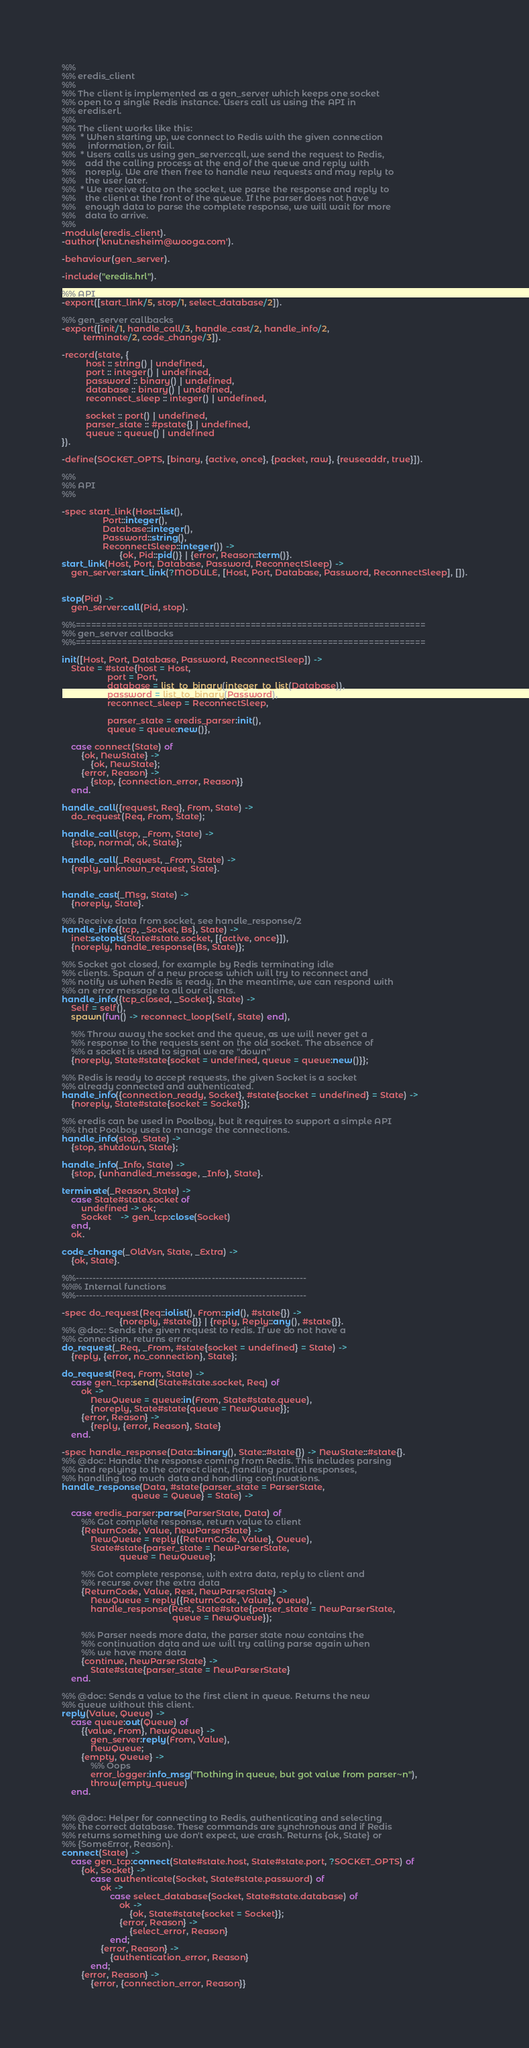Convert code to text. <code><loc_0><loc_0><loc_500><loc_500><_Erlang_>%%
%% eredis_client
%%
%% The client is implemented as a gen_server which keeps one socket
%% open to a single Redis instance. Users call us using the API in
%% eredis.erl.
%%
%% The client works like this:
%%  * When starting up, we connect to Redis with the given connection
%%     information, or fail.
%%  * Users calls us using gen_server:call, we send the request to Redis,
%%    add the calling process at the end of the queue and reply with
%%    noreply. We are then free to handle new requests and may reply to
%%    the user later.
%%  * We receive data on the socket, we parse the response and reply to
%%    the client at the front of the queue. If the parser does not have
%%    enough data to parse the complete response, we will wait for more
%%    data to arrive.
%%
-module(eredis_client).
-author('knut.nesheim@wooga.com').

-behaviour(gen_server).

-include("eredis.hrl").

%% API
-export([start_link/5, stop/1, select_database/2]).

%% gen_server callbacks
-export([init/1, handle_call/3, handle_cast/2, handle_info/2,
         terminate/2, code_change/3]).

-record(state, {
          host :: string() | undefined,
          port :: integer() | undefined,
          password :: binary() | undefined,
          database :: binary() | undefined,
          reconnect_sleep :: integer() | undefined,

          socket :: port() | undefined,
          parser_state :: #pstate{} | undefined,
          queue :: queue() | undefined
}).

-define(SOCKET_OPTS, [binary, {active, once}, {packet, raw}, {reuseaddr, true}]).

%%
%% API
%%

-spec start_link(Host::list(),
                 Port::integer(),
                 Database::integer(),
                 Password::string(),
                 ReconnectSleep::integer()) ->
                        {ok, Pid::pid()} | {error, Reason::term()}.
start_link(Host, Port, Database, Password, ReconnectSleep) ->
    gen_server:start_link(?MODULE, [Host, Port, Database, Password, ReconnectSleep], []).


stop(Pid) ->
    gen_server:call(Pid, stop).

%%====================================================================
%% gen_server callbacks
%%====================================================================

init([Host, Port, Database, Password, ReconnectSleep]) ->
    State = #state{host = Host,
                   port = Port,
                   database = list_to_binary(integer_to_list(Database)),
                   password = list_to_binary(Password),
                   reconnect_sleep = ReconnectSleep,

                   parser_state = eredis_parser:init(),
                   queue = queue:new()},

    case connect(State) of
        {ok, NewState} ->
            {ok, NewState};
        {error, Reason} ->
            {stop, {connection_error, Reason}}
    end.

handle_call({request, Req}, From, State) ->
    do_request(Req, From, State);

handle_call(stop, _From, State) ->
    {stop, normal, ok, State};

handle_call(_Request, _From, State) ->
    {reply, unknown_request, State}.


handle_cast(_Msg, State) ->
    {noreply, State}.

%% Receive data from socket, see handle_response/2
handle_info({tcp, _Socket, Bs}, State) ->
    inet:setopts(State#state.socket, [{active, once}]),
    {noreply, handle_response(Bs, State)};

%% Socket got closed, for example by Redis terminating idle
%% clients. Spawn of a new process which will try to reconnect and
%% notify us when Redis is ready. In the meantime, we can respond with
%% an error message to all our clients.
handle_info({tcp_closed, _Socket}, State) ->
    Self = self(),
    spawn(fun() -> reconnect_loop(Self, State) end),

    %% Throw away the socket and the queue, as we will never get a
    %% response to the requests sent on the old socket. The absence of
    %% a socket is used to signal we are "down"
    {noreply, State#state{socket = undefined, queue = queue:new()}};

%% Redis is ready to accept requests, the given Socket is a socket
%% already connected and authenticated.
handle_info({connection_ready, Socket}, #state{socket = undefined} = State) ->
    {noreply, State#state{socket = Socket}};

%% eredis can be used in Poolboy, but it requires to support a simple API
%% that Poolboy uses to manage the connections.
handle_info(stop, State) ->
    {stop, shutdown, State};

handle_info(_Info, State) ->
    {stop, {unhandled_message, _Info}, State}.

terminate(_Reason, State) ->
    case State#state.socket of
        undefined -> ok;
        Socket    -> gen_tcp:close(Socket)
    end,
    ok.

code_change(_OldVsn, State, _Extra) ->
    {ok, State}.

%%--------------------------------------------------------------------
%%% Internal functions
%%--------------------------------------------------------------------

-spec do_request(Req::iolist(), From::pid(), #state{}) ->
                        {noreply, #state{}} | {reply, Reply::any(), #state{}}.
%% @doc: Sends the given request to redis. If we do not have a
%% connection, returns error.
do_request(_Req, _From, #state{socket = undefined} = State) ->
    {reply, {error, no_connection}, State};

do_request(Req, From, State) ->
    case gen_tcp:send(State#state.socket, Req) of
        ok ->
            NewQueue = queue:in(From, State#state.queue),
            {noreply, State#state{queue = NewQueue}};
        {error, Reason} ->
            {reply, {error, Reason}, State}
    end.

-spec handle_response(Data::binary(), State::#state{}) -> NewState::#state{}.
%% @doc: Handle the response coming from Redis. This includes parsing
%% and replying to the correct client, handling partial responses,
%% handling too much data and handling continuations.
handle_response(Data, #state{parser_state = ParserState,
                             queue = Queue} = State) ->

    case eredis_parser:parse(ParserState, Data) of
        %% Got complete response, return value to client
        {ReturnCode, Value, NewParserState} ->
            NewQueue = reply({ReturnCode, Value}, Queue),
            State#state{parser_state = NewParserState,
                        queue = NewQueue};

        %% Got complete response, with extra data, reply to client and
        %% recurse over the extra data
        {ReturnCode, Value, Rest, NewParserState} ->
            NewQueue = reply({ReturnCode, Value}, Queue),
            handle_response(Rest, State#state{parser_state = NewParserState,
                                              queue = NewQueue});

        %% Parser needs more data, the parser state now contains the
        %% continuation data and we will try calling parse again when
        %% we have more data
        {continue, NewParserState} ->
            State#state{parser_state = NewParserState}
    end.

%% @doc: Sends a value to the first client in queue. Returns the new
%% queue without this client.
reply(Value, Queue) ->
    case queue:out(Queue) of
        {{value, From}, NewQueue} ->
            gen_server:reply(From, Value),
            NewQueue;
        {empty, Queue} ->
            %% Oops
            error_logger:info_msg("Nothing in queue, but got value from parser~n"),
            throw(empty_queue)
    end.


%% @doc: Helper for connecting to Redis, authenticating and selecting
%% the correct database. These commands are synchronous and if Redis
%% returns something we don't expect, we crash. Returns {ok, State} or
%% {SomeError, Reason}.
connect(State) ->
    case gen_tcp:connect(State#state.host, State#state.port, ?SOCKET_OPTS) of
        {ok, Socket} ->
            case authenticate(Socket, State#state.password) of
                ok ->
                    case select_database(Socket, State#state.database) of
                        ok ->
                            {ok, State#state{socket = Socket}};
                        {error, Reason} ->
                            {select_error, Reason}
                    end;
                {error, Reason} ->
                    {authentication_error, Reason}
            end;
        {error, Reason} ->
            {error, {connection_error, Reason}}</code> 